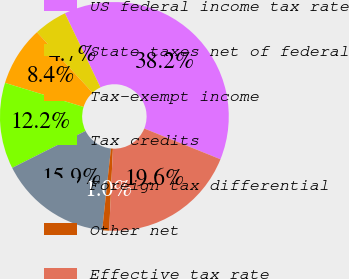Convert chart to OTSL. <chart><loc_0><loc_0><loc_500><loc_500><pie_chart><fcel>US federal income tax rate<fcel>State taxes net of federal<fcel>Tax-exempt income<fcel>Tax credits<fcel>Foreign tax differential<fcel>Other net<fcel>Effective tax rate<nl><fcel>38.23%<fcel>4.71%<fcel>8.43%<fcel>12.16%<fcel>15.88%<fcel>0.98%<fcel>19.61%<nl></chart> 